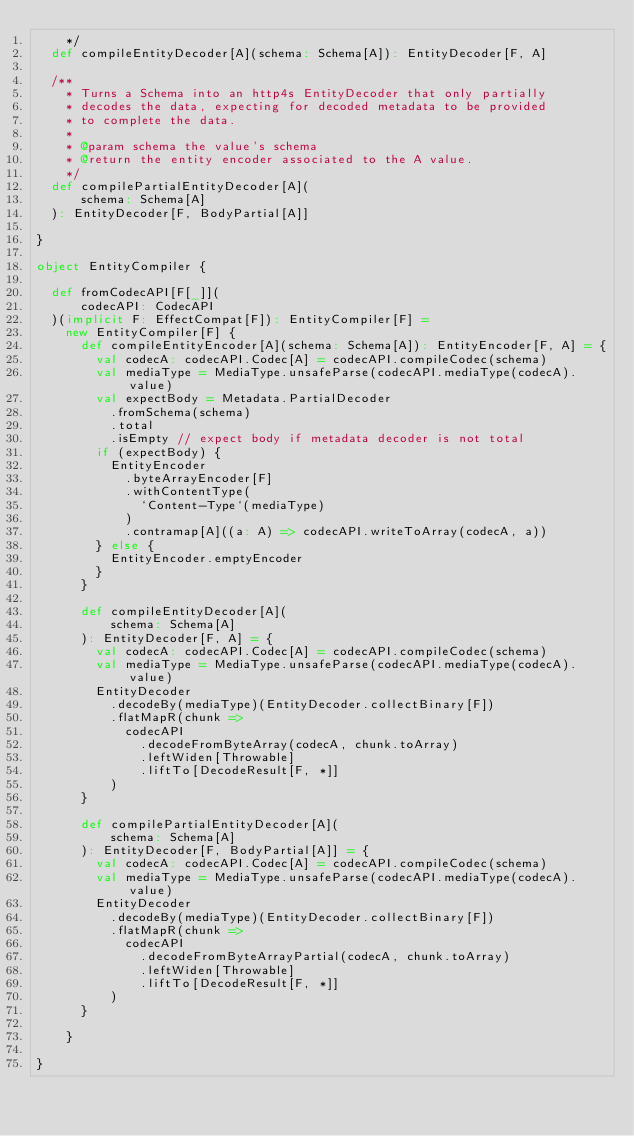<code> <loc_0><loc_0><loc_500><loc_500><_Scala_>    */
  def compileEntityDecoder[A](schema: Schema[A]): EntityDecoder[F, A]

  /**
    * Turns a Schema into an http4s EntityDecoder that only partially
    * decodes the data, expecting for decoded metadata to be provided
    * to complete the data.
    *
    * @param schema the value's schema
    * @return the entity encoder associated to the A value.
    */
  def compilePartialEntityDecoder[A](
      schema: Schema[A]
  ): EntityDecoder[F, BodyPartial[A]]

}

object EntityCompiler {

  def fromCodecAPI[F[_]](
      codecAPI: CodecAPI
  )(implicit F: EffectCompat[F]): EntityCompiler[F] =
    new EntityCompiler[F] {
      def compileEntityEncoder[A](schema: Schema[A]): EntityEncoder[F, A] = {
        val codecA: codecAPI.Codec[A] = codecAPI.compileCodec(schema)
        val mediaType = MediaType.unsafeParse(codecAPI.mediaType(codecA).value)
        val expectBody = Metadata.PartialDecoder
          .fromSchema(schema)
          .total
          .isEmpty // expect body if metadata decoder is not total
        if (expectBody) {
          EntityEncoder
            .byteArrayEncoder[F]
            .withContentType(
              `Content-Type`(mediaType)
            )
            .contramap[A]((a: A) => codecAPI.writeToArray(codecA, a))
        } else {
          EntityEncoder.emptyEncoder
        }
      }

      def compileEntityDecoder[A](
          schema: Schema[A]
      ): EntityDecoder[F, A] = {
        val codecA: codecAPI.Codec[A] = codecAPI.compileCodec(schema)
        val mediaType = MediaType.unsafeParse(codecAPI.mediaType(codecA).value)
        EntityDecoder
          .decodeBy(mediaType)(EntityDecoder.collectBinary[F])
          .flatMapR(chunk =>
            codecAPI
              .decodeFromByteArray(codecA, chunk.toArray)
              .leftWiden[Throwable]
              .liftTo[DecodeResult[F, *]]
          )
      }

      def compilePartialEntityDecoder[A](
          schema: Schema[A]
      ): EntityDecoder[F, BodyPartial[A]] = {
        val codecA: codecAPI.Codec[A] = codecAPI.compileCodec(schema)
        val mediaType = MediaType.unsafeParse(codecAPI.mediaType(codecA).value)
        EntityDecoder
          .decodeBy(mediaType)(EntityDecoder.collectBinary[F])
          .flatMapR(chunk =>
            codecAPI
              .decodeFromByteArrayPartial(codecA, chunk.toArray)
              .leftWiden[Throwable]
              .liftTo[DecodeResult[F, *]]
          )
      }

    }

}
</code> 